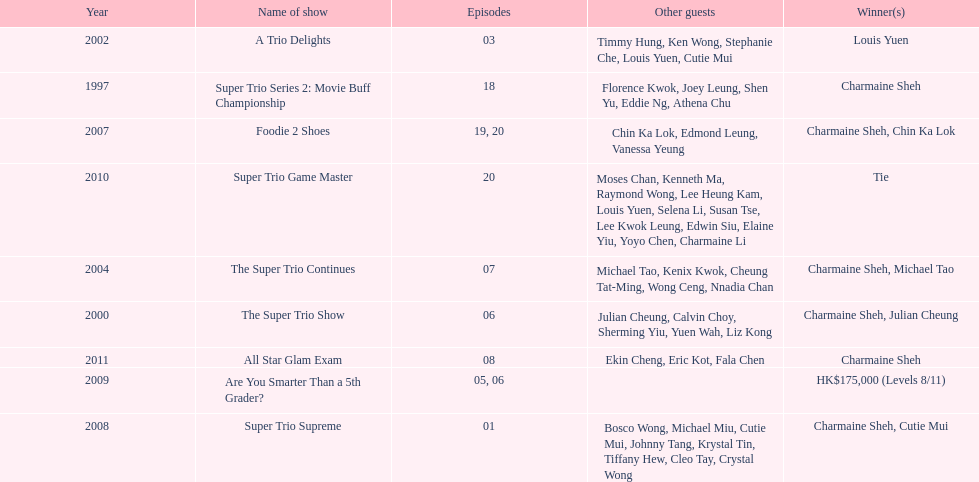What year was the only year were a tie occurred? 2010. 